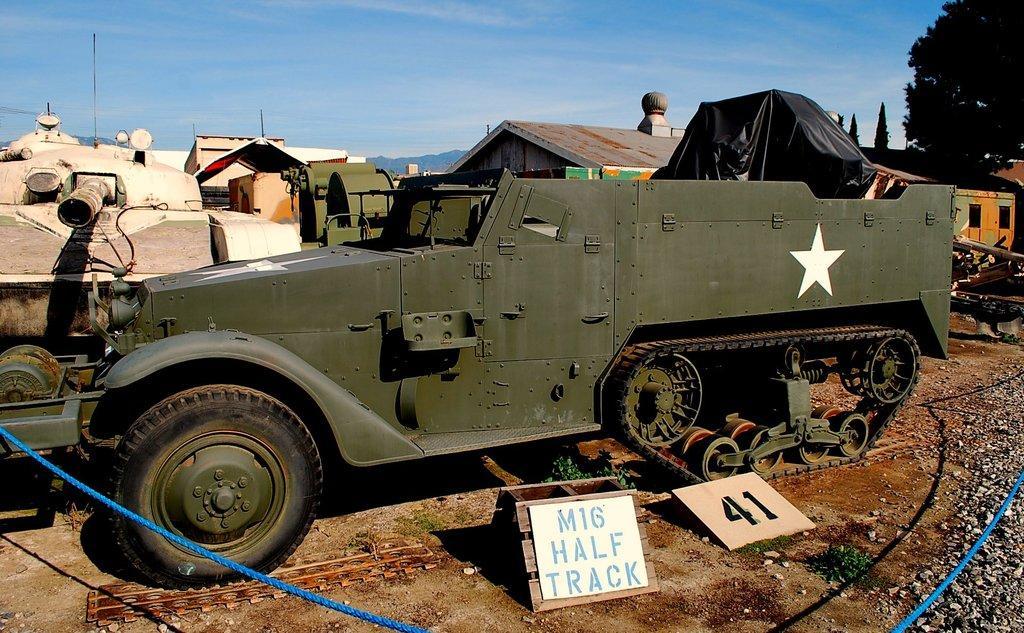Please provide a concise description of this image. In this image we can see motor vehicles placed on the ground, shrubs, stones, pipelines, ropes, building, trees and sky with clouds. 